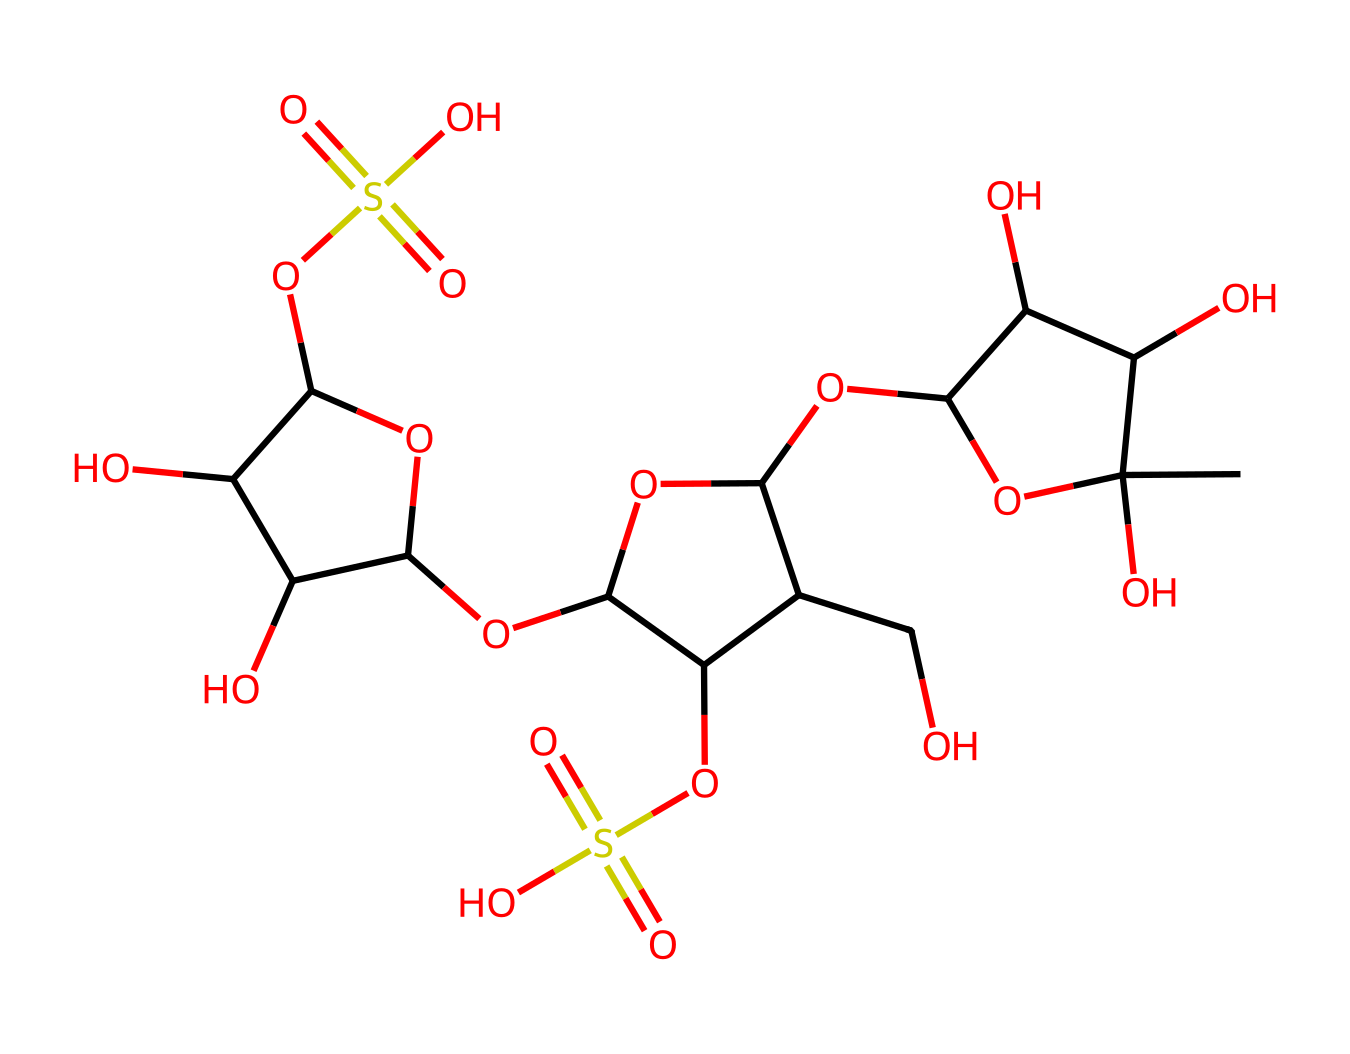What is the molecular formula of this chemical? By analyzing the SMILES representation, we identify the different atom types present. In the structure, we have carbon (C), hydrogen (H), oxygen (O), and sulfur (S) atoms. Counting each atom based on the SMILES, we derive the molecular formula as C14H21O10S2.
Answer: C14H21O10S2 How many sulfur atoms are in the chemical structure? Looking at the SMILES representation, we can see that the part "S(=O)(=O)" signifies a sulfur atom bonded to two oxygen atoms. By scanning through the entire structure, we find there are two such instances of sulfur.
Answer: 2 What type of food additive is carrageenan categorized as? Carrageenan is classified based on its application, which is as a thickening or gelling agent in food products. This is commonly known from its use in dairy products and plant-based milk alternatives.
Answer: thickening agent How does the presence of sulfate groups affect the properties of carrageenan? The sulfate groups (indicated by "S(=O)(=O)") contribute to the solubility of carrageenan in water, which is a characteristic that enhances its thickening ability. This interaction with water leads to its effectiveness in forming gels and stabilizing emulsions.
Answer: enhances solubility What are the potential health concerns related to consuming carrageenan? Some studies suggest that carrageenan may cause inflammation and digestive issues in certain individuals, which are based on its chemical structure and interaction within the gastrointestinal tract. While more research is needed, some consumers may experience adverse effects.
Answer: inflammation concerns 